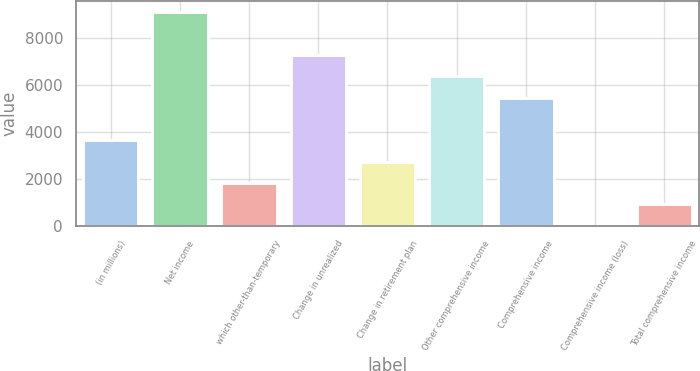Convert chart to OTSL. <chart><loc_0><loc_0><loc_500><loc_500><bar_chart><fcel>(in millions)<fcel>Net income<fcel>which other-than-temporary<fcel>Change in unrealized<fcel>Change in retirement plan<fcel>Other comprehensive income<fcel>Comprehensive income<fcel>Comprehensive income (loss)<fcel>Total comprehensive income<nl><fcel>3646.4<fcel>9092<fcel>1831.2<fcel>7276.8<fcel>2738.8<fcel>6369.2<fcel>5461.6<fcel>16<fcel>923.6<nl></chart> 